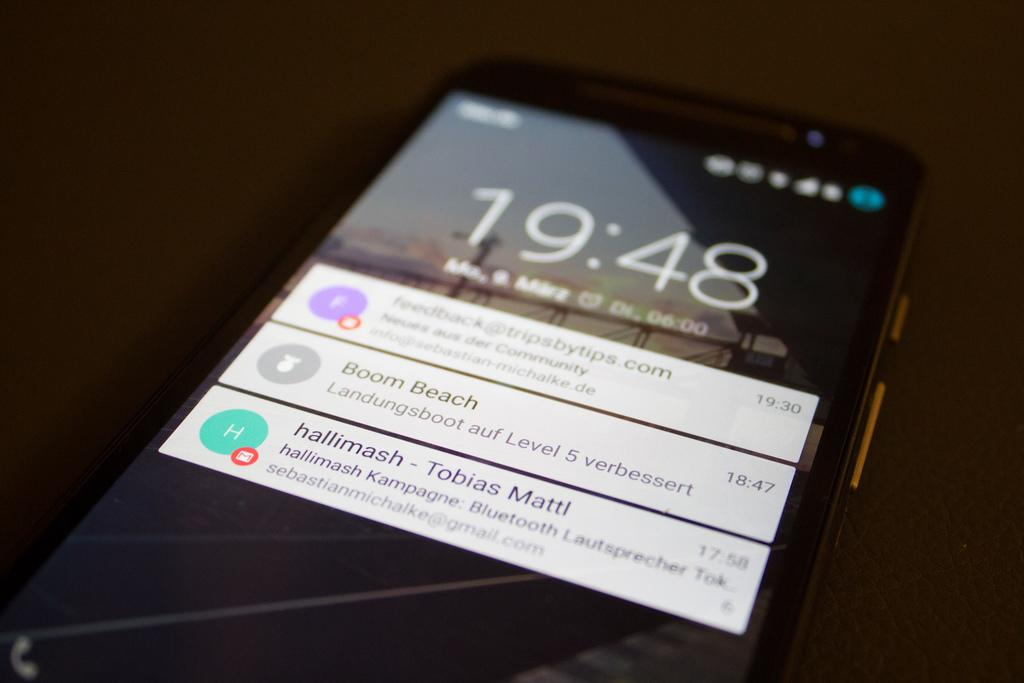<image>
Describe the image concisely. Messages and the time show on the screen of a cellphone at 19:48. 